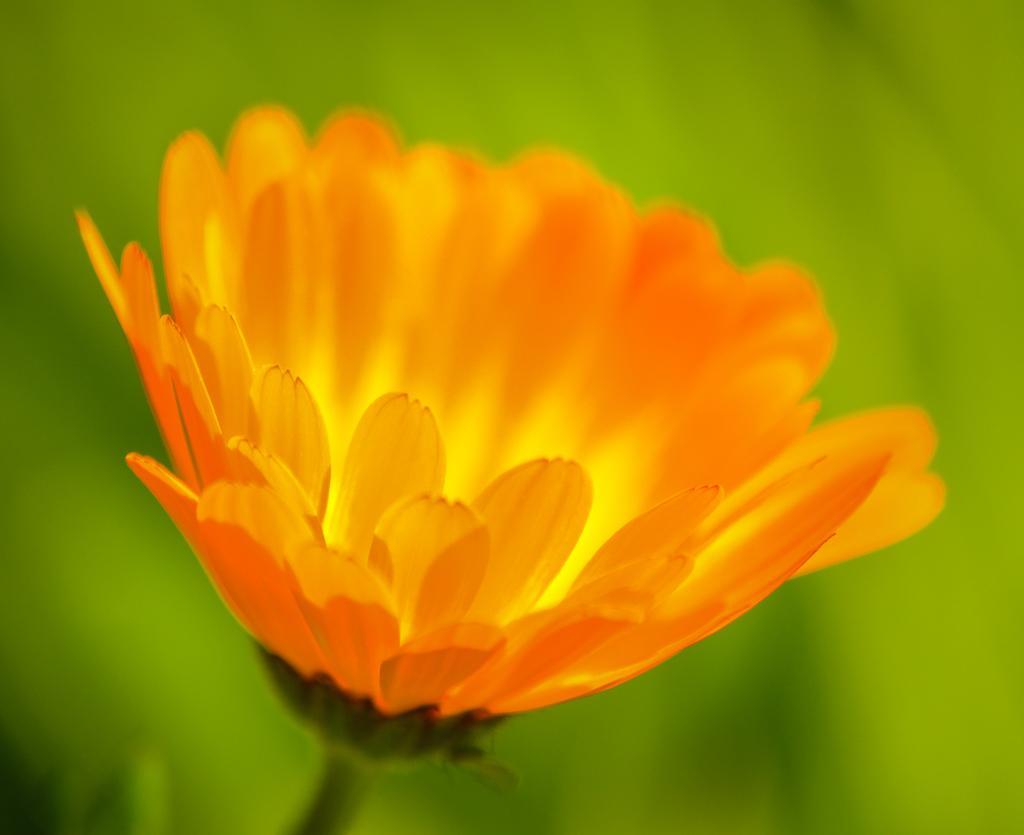Can you describe this image briefly? In this picture we can see a flower. In the background of the image it is blue and green. 